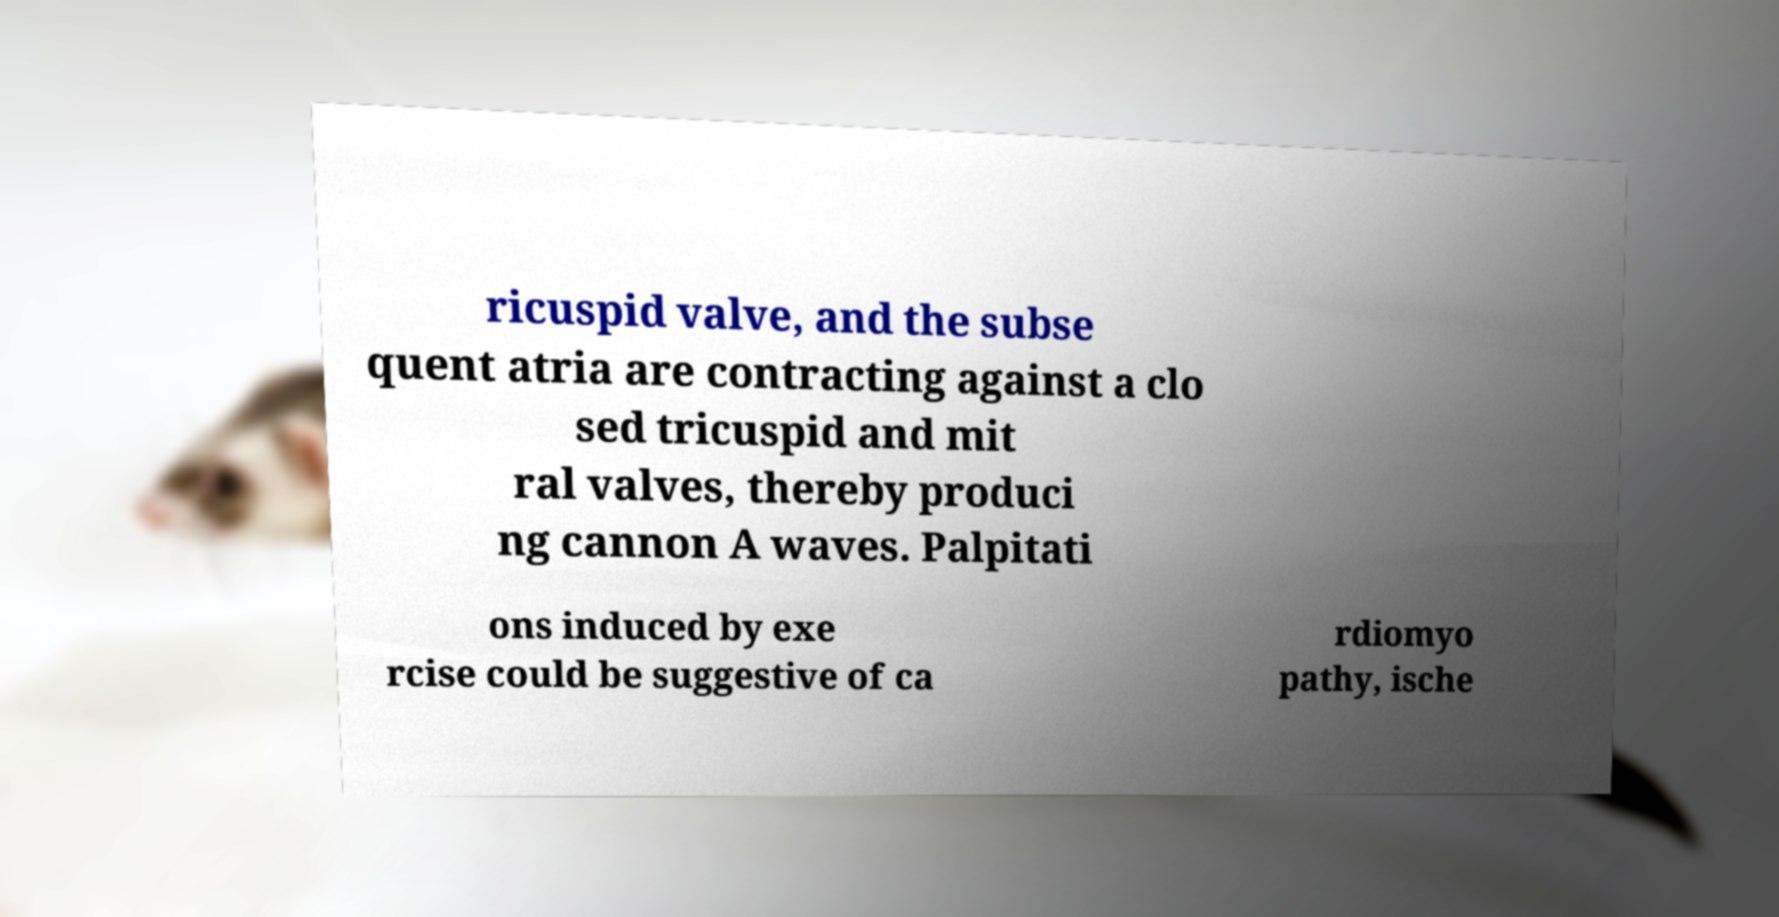Please read and relay the text visible in this image. What does it say? ricuspid valve, and the subse quent atria are contracting against a clo sed tricuspid and mit ral valves, thereby produci ng cannon A waves. Palpitati ons induced by exe rcise could be suggestive of ca rdiomyo pathy, ische 